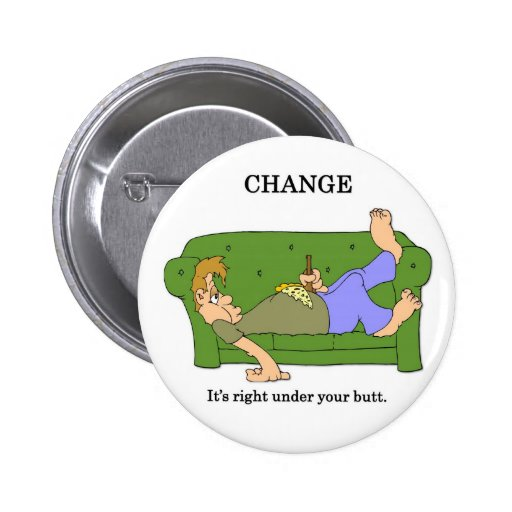Can you describe the humor and significance of the image in the context of daily life? The humor in the image stems from a clever visual pun. It captures a relatable scenario where people often find loose change under the couch cushions. This literal interpretation humorously aligns with the metaphorical idea that significant changes in life can start from simple, everyday actions. The significance in daily life is a playful reminder that opportunities and possibilities for change are often closer than we think, encouraging a proactive approach even from a state of rest. 